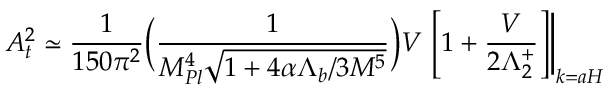Convert formula to latex. <formula><loc_0><loc_0><loc_500><loc_500>A _ { t } ^ { 2 } \simeq \frac { 1 } { 1 5 0 \pi ^ { 2 } } \left ( \frac { 1 } { M _ { P l } ^ { 4 } \sqrt { 1 + 4 \alpha \Lambda _ { b } / 3 M ^ { 5 } } } \right ) V \left [ 1 + \frac { V } { 2 \Lambda _ { 2 } ^ { + } } \right ] \right | _ { k = a H } \,</formula> 